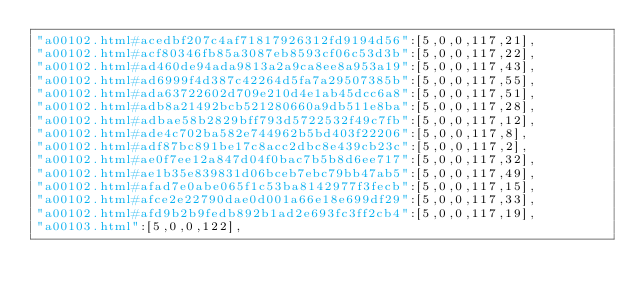<code> <loc_0><loc_0><loc_500><loc_500><_JavaScript_>"a00102.html#acedbf207c4af71817926312fd9194d56":[5,0,0,117,21],
"a00102.html#acf80346fb85a3087eb8593cf06c53d3b":[5,0,0,117,22],
"a00102.html#ad460de94ada9813a2a9ca8ee8a953a19":[5,0,0,117,43],
"a00102.html#ad6999f4d387c42264d5fa7a29507385b":[5,0,0,117,55],
"a00102.html#ada63722602d709e210d4e1ab45dcc6a8":[5,0,0,117,51],
"a00102.html#adb8a21492bcb521280660a9db511e8ba":[5,0,0,117,28],
"a00102.html#adbae58b2829bff793d5722532f49c7fb":[5,0,0,117,12],
"a00102.html#ade4c702ba582e744962b5bd403f22206":[5,0,0,117,8],
"a00102.html#adf87bc891be17c8acc2dbc8e439cb23c":[5,0,0,117,2],
"a00102.html#ae0f7ee12a847d04f0bac7b5b8d6ee717":[5,0,0,117,32],
"a00102.html#ae1b35e839831d06bceb7ebc79bb47ab5":[5,0,0,117,49],
"a00102.html#afad7e0abe065f1c53ba8142977f3fecb":[5,0,0,117,15],
"a00102.html#afce2e22790dae0d001a66e18e699df29":[5,0,0,117,33],
"a00102.html#afd9b2b9fedb892b1ad2e693fc3ff2cb4":[5,0,0,117,19],
"a00103.html":[5,0,0,122],</code> 